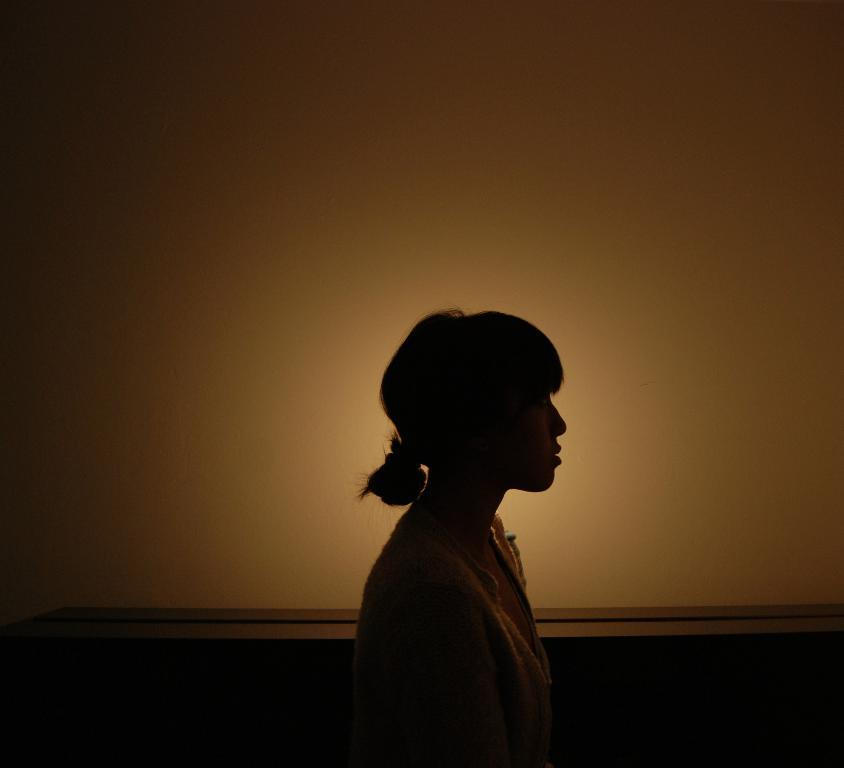What is the main subject of the image? The main subject of the image is a person standing. What can be seen in the background of the image? There is an object that looks like a wall in the image. Can you describe the jar that the person is holding in the image? There is no jar present in the image; the person is not holding any object. How many buns can be seen on the person's head in the image? There are no buns visible on the person's head in the image. 